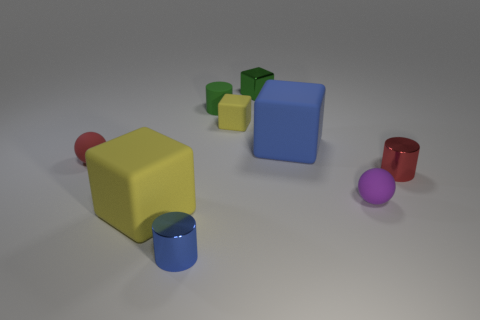Subtract all red cylinders. How many cylinders are left? 2 Add 1 blue blocks. How many objects exist? 10 Subtract all blue cylinders. How many yellow blocks are left? 2 Subtract 1 blocks. How many blocks are left? 3 Subtract all red cylinders. How many cylinders are left? 2 Subtract all red cylinders. Subtract all brown balls. How many cylinders are left? 2 Subtract all small blue objects. Subtract all purple metallic blocks. How many objects are left? 8 Add 4 blue metallic objects. How many blue metallic objects are left? 5 Add 7 small purple things. How many small purple things exist? 8 Subtract 1 blue blocks. How many objects are left? 8 